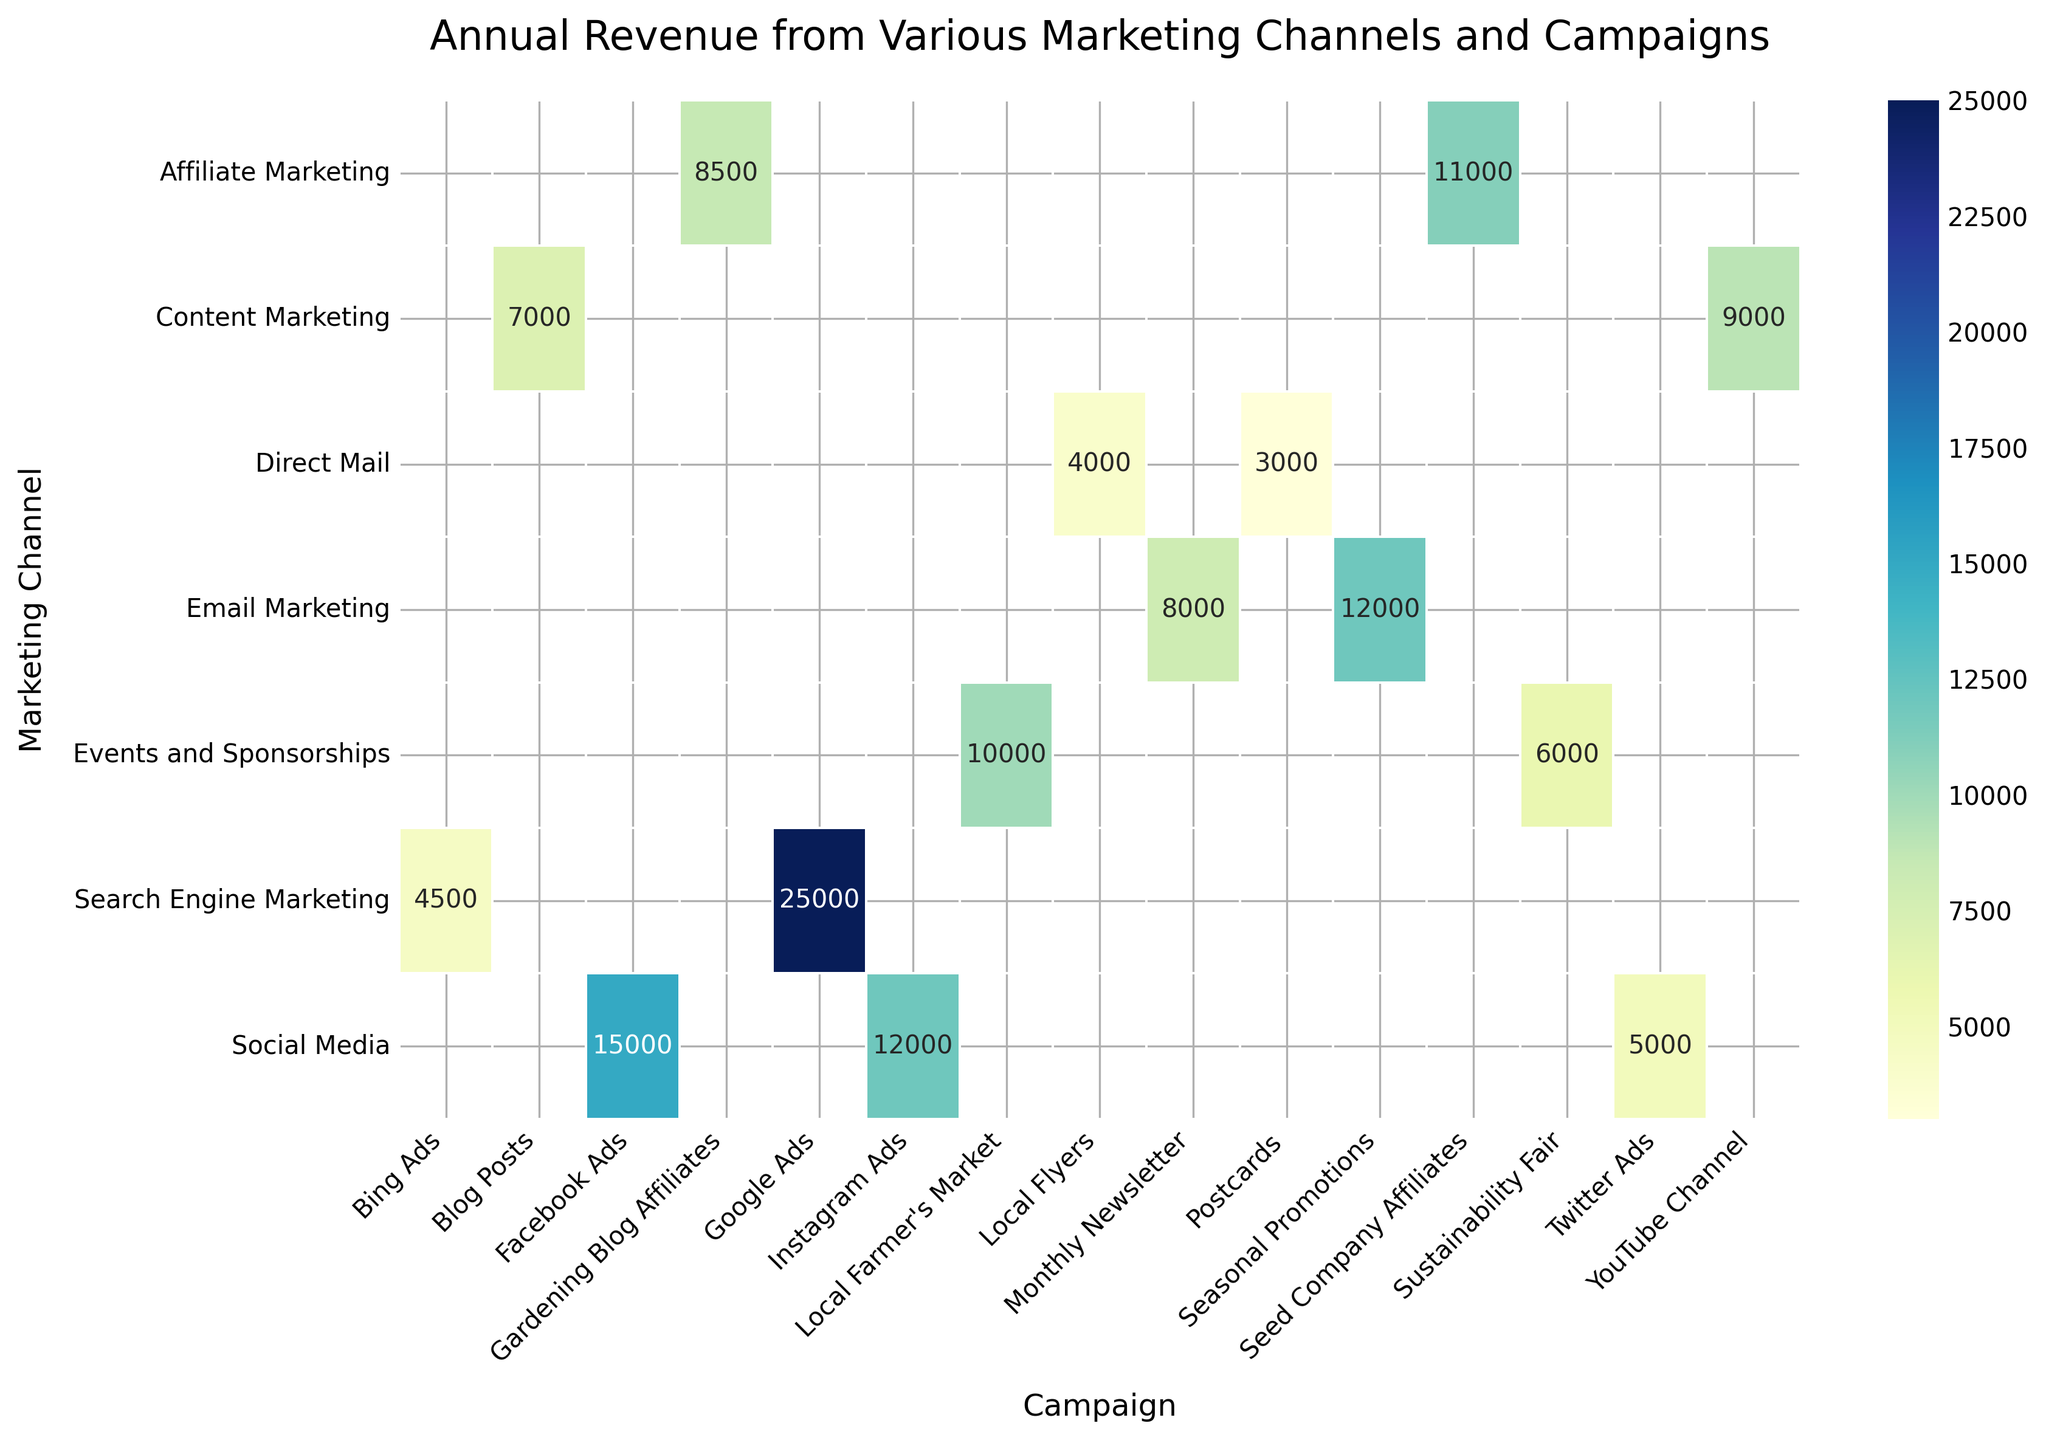What's the title of the heatmap? The title of a figure is usually found at the top and is often larger or in bold text to distinguish it from other elements. This helps users quickly understand the main topic.
Answer: Annual Revenue from Various Marketing Channels and Campaigns Which marketing channel has the highest annual revenue in the heatmap? To find the highest annual revenue, locate the cell with the highest value in the heatmap and check the corresponding marketing channel. The color intensity can also guide you to the highest value.
Answer: Search Engine Marketing What is the total annual revenue from Email Marketing campaigns? Sum the annual revenues of the campaigns under the 'Email Marketing' channel: 8000 (Monthly Newsletter) + 12000 (Seasonal Promotions).
Answer: 20000 Compare the annual revenue from 'Google Ads' and 'Instagram Ads'. Which one is higher? Locate the revenue values for both Google Ads and Instagram Ads and compare them. 'Google Ads' has a revenue of 25000 and 'Instagram Ads' has 12000.
Answer: Google Ads Which campaign in 'Affiliate Marketing' generates more revenue, and by how much? Check the revenues of the campaigns under 'Affiliate Marketing': 'Seed Company Affiliates' (11000) and 'Gardening Blog Affiliates' (8500). Subtract the smaller value from the larger value.
Answer: Seed Company Affiliates by 2500 What is the average annual revenue for the 'Direct Mail' marketing channel? To find the average, sum the revenues of the 'Direct Mail' campaigns (Local Flyers and Postcards) and divide by the number of campaigns: (4000 + 3000) / 2.
Answer: 3500 Which campaign has the lowest annual revenue, and what is its value? Check all the cells and find the one with the lowest value. The color intensity can guide you to the lowest value.
Answer: Postcards, 3000 What are the total annual revenues from 'Content Marketing' and 'Affiliate Marketing'? Sum the revenue values under 'Content Marketing' campaigns and 'Affiliate Marketing' campaigns separately. Content Marketing: 7000 + 9000 = 16000, Affiliate Marketing: 11000 + 8500 = 19500. The total is 16000 + 19500.
Answer: 35500 Compare the annual revenues from 'Local Farmer's Market' and 'Sustainability Fair'. How much more does the higher one generate? Locate the revenues for both campaigns. 'Local Farmer's Market' has 10000 and 'Sustainability Fair' has 6000. Subtract the smaller value from the larger value.
Answer: Local Farmer's Market by 4000 Which marketing channel has the most diverse campaign revenue spread based on visual inspection of the heatmap colors? Visual diversity in revenue can be gauged by the spread and variation in color intensity within a channel's row. Look for the row with the widest range of color shades.
Answer: Social Media 